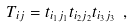<formula> <loc_0><loc_0><loc_500><loc_500>T _ { i j } = t _ { i _ { 1 } j _ { 1 } } t _ { i _ { 2 } j _ { 2 } } t _ { i _ { 3 } j _ { 3 } } \ ,</formula> 